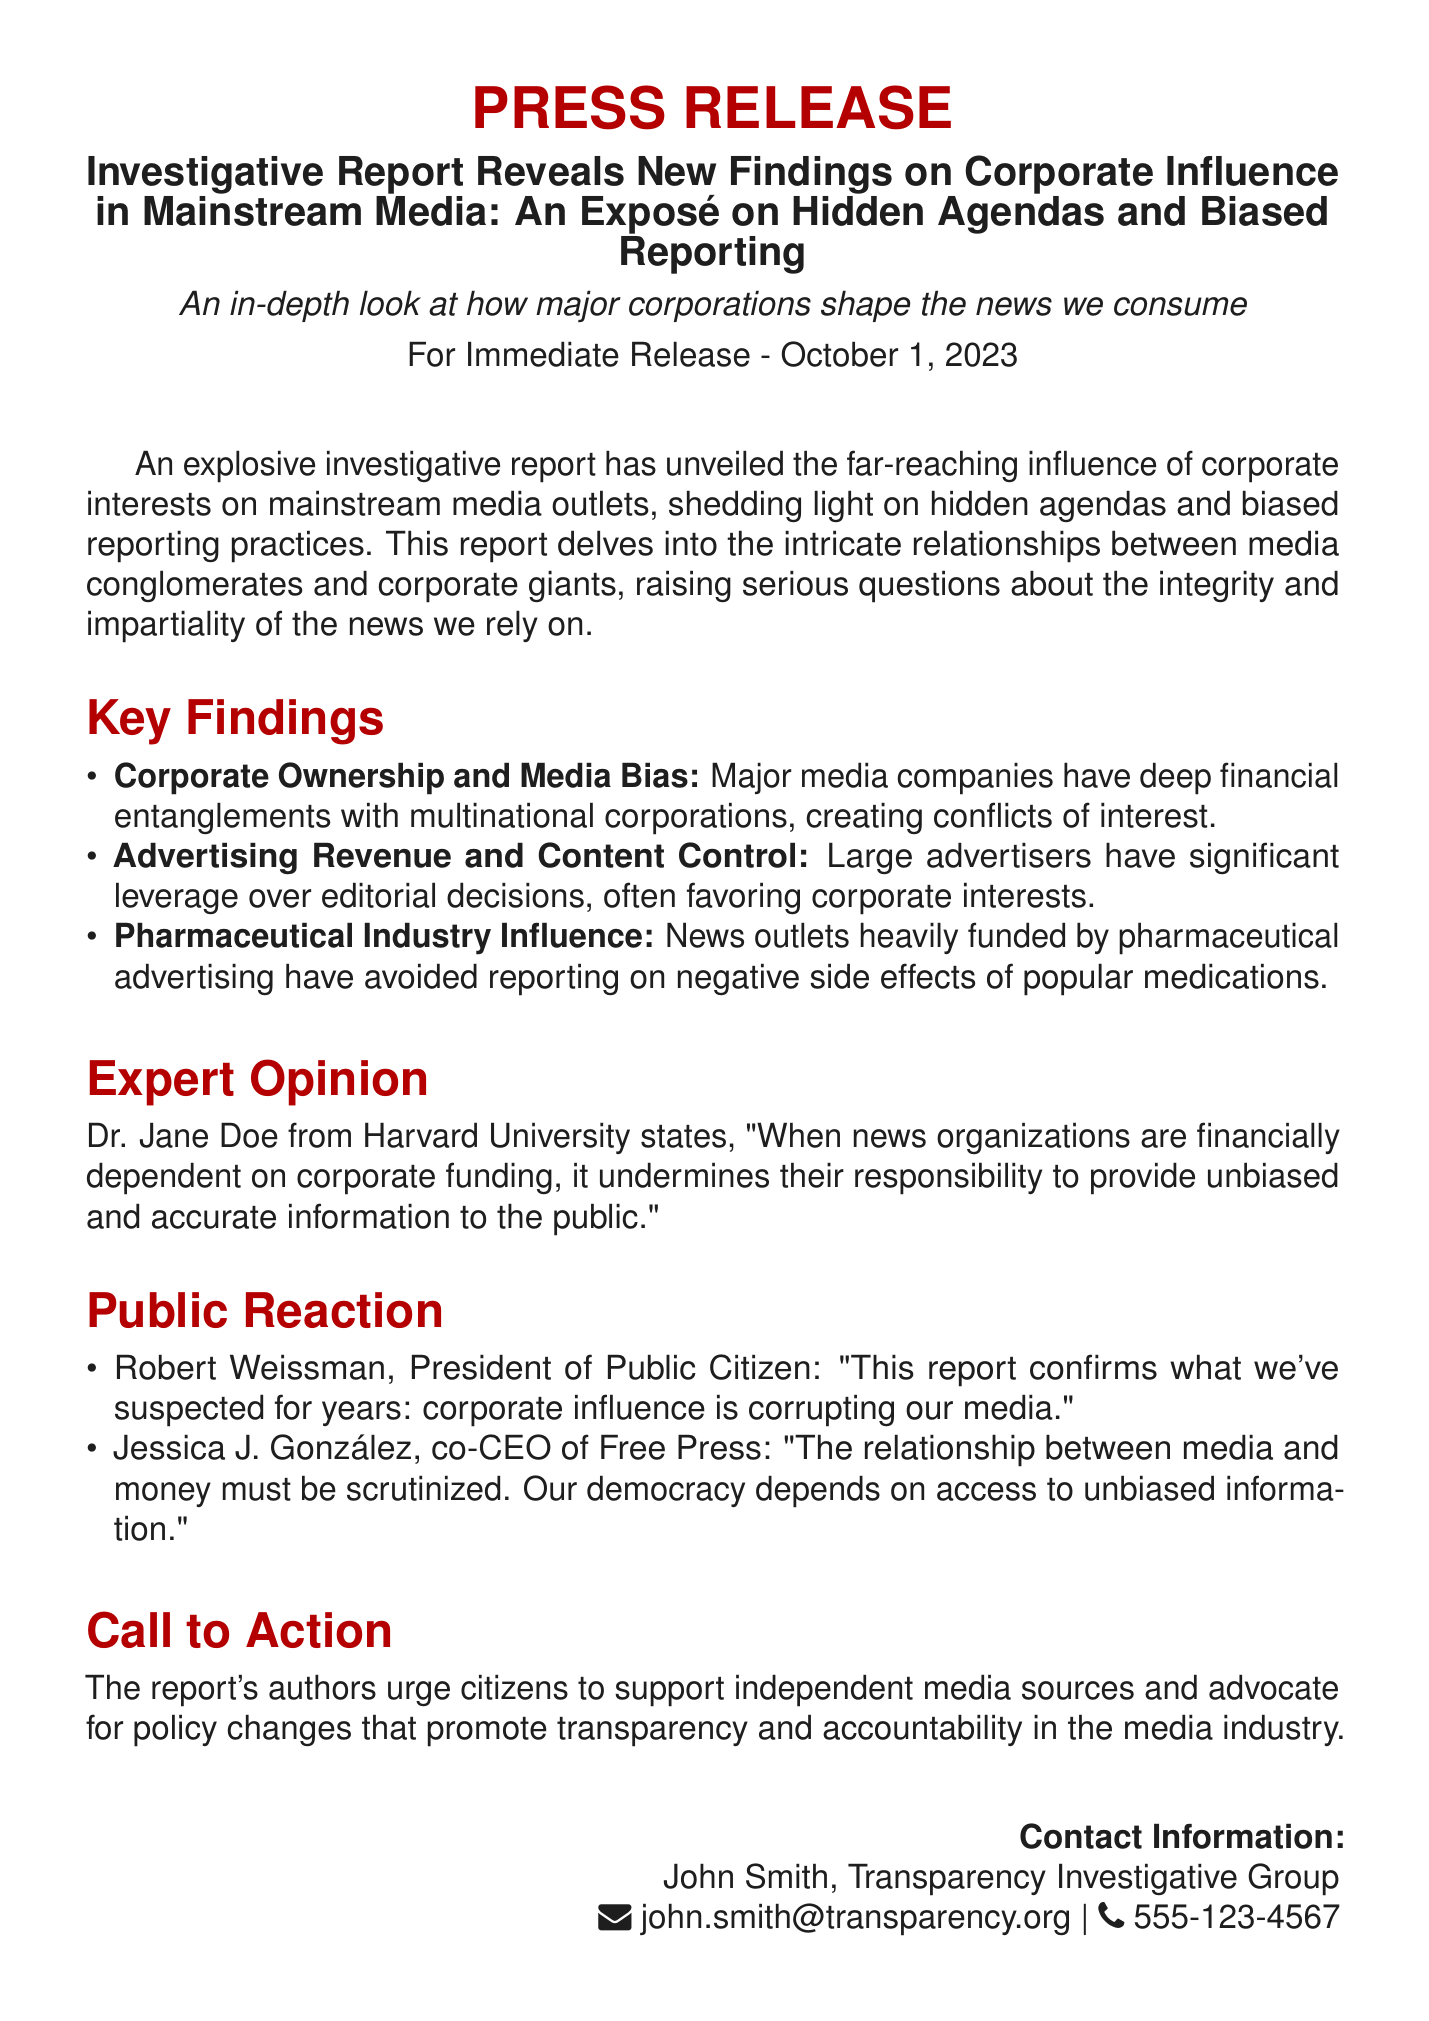What is the title of the report? The title of the report is mentioned at the beginning of the document under the press release section.
Answer: Investigative Report Reveals New Findings on Corporate Influence in Mainstream Media: An Exposé on Hidden Agendas and Biased Reporting What is the release date of this press release? The release date is stated clearly in the document, indicating when the information was made public.
Answer: October 1, 2023 Who is the contact person for this press release? The document specifies a contact person for inquiries related to the press release.
Answer: John Smith What is one key finding about corporate ownership? The document lists important findings regarding the relationship between media companies and corporations.
Answer: Major media companies have deep financial entanglements with multinational corporations, creating conflicts of interest What does Dr. Jane Doe claim about corporate funding? The document features a quote from an expert in the field regarding corporate funding of news organizations.
Answer: It undermines their responsibility to provide unbiased and accurate information to the public What organization does Robert Weissman represent? The document mentions who Robert Weissman is and his position within a certain organization.
Answer: Public Citizen What do the authors urge citizens to do? The document provides a clear call to action from the report's authors concerning media consumption.
Answer: Support independent media sources Why is access to unbiased information important, according to Jessica J. González? The document includes a statement made by Jessica J. González about the implications of media relationships.
Answer: Our democracy depends on access to unbiased information 